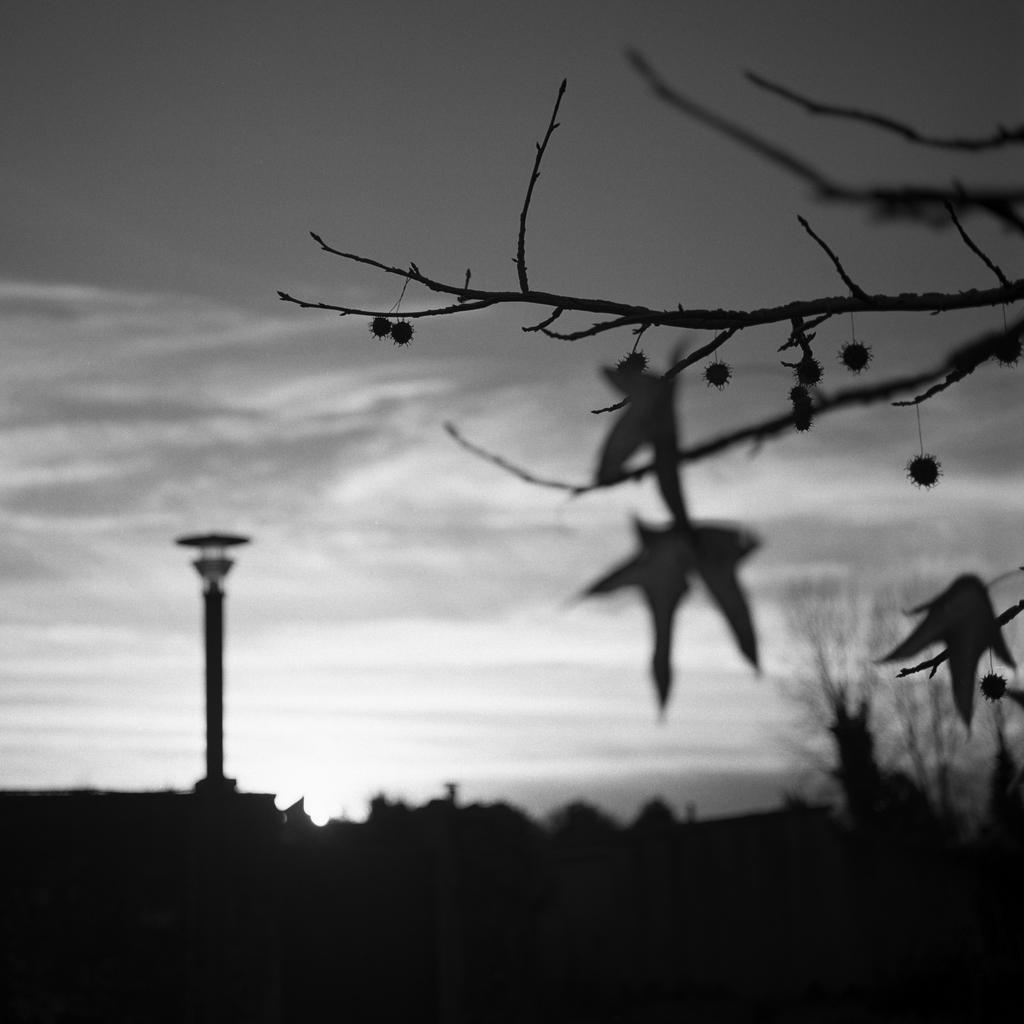Can you describe this image briefly? In this picture there is a tree which has few objects on it and there is a tower and there are few other objects beside it. 